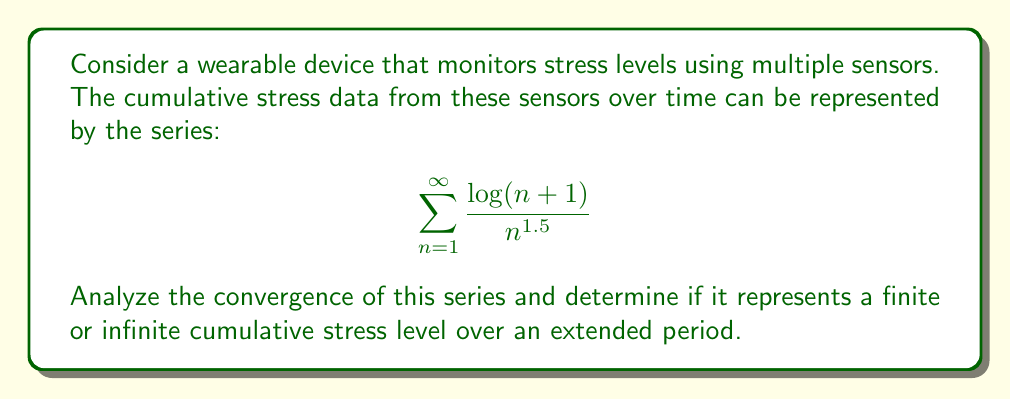Give your solution to this math problem. To analyze the convergence of this series, we can use the limit comparison test with a known series. Let's compare it to the p-series $\sum_{n=1}^{\infty} \frac{1}{n^p}$ where $p = 1.5$.

Step 1: Set up the limit comparison.
Let $a_n = \frac{\log(n+1)}{n^{1.5}}$ and $b_n = \frac{1}{n^{1.5}}$.

$$\lim_{n \to \infty} \frac{a_n}{b_n} = \lim_{n \to \infty} \frac{\frac{\log(n+1)}{n^{1.5}}}{\frac{1}{n^{1.5}}} = \lim_{n \to \infty} \log(n+1)$$

Step 2: Evaluate the limit.
$$\lim_{n \to \infty} \log(n+1) = \infty$$

Step 3: Interpret the result.
Since the limit is infinite and positive, by the limit comparison test, both series either both converge or both diverge.

Step 4: Determine the convergence of the p-series.
The p-series $\sum_{n=1}^{\infty} \frac{1}{n^p}$ converges for $p > 1$. In this case, $p = 1.5 > 1$, so the p-series converges.

Step 5: Conclude about the original series.
Since the p-series converges and the limit comparison test shows that both series behave similarly, we can conclude that the original series $\sum_{n=1}^{\infty} \frac{\log(n+1)}{n^{1.5}}$ also converges.
Answer: The series converges, representing a finite cumulative stress level. 